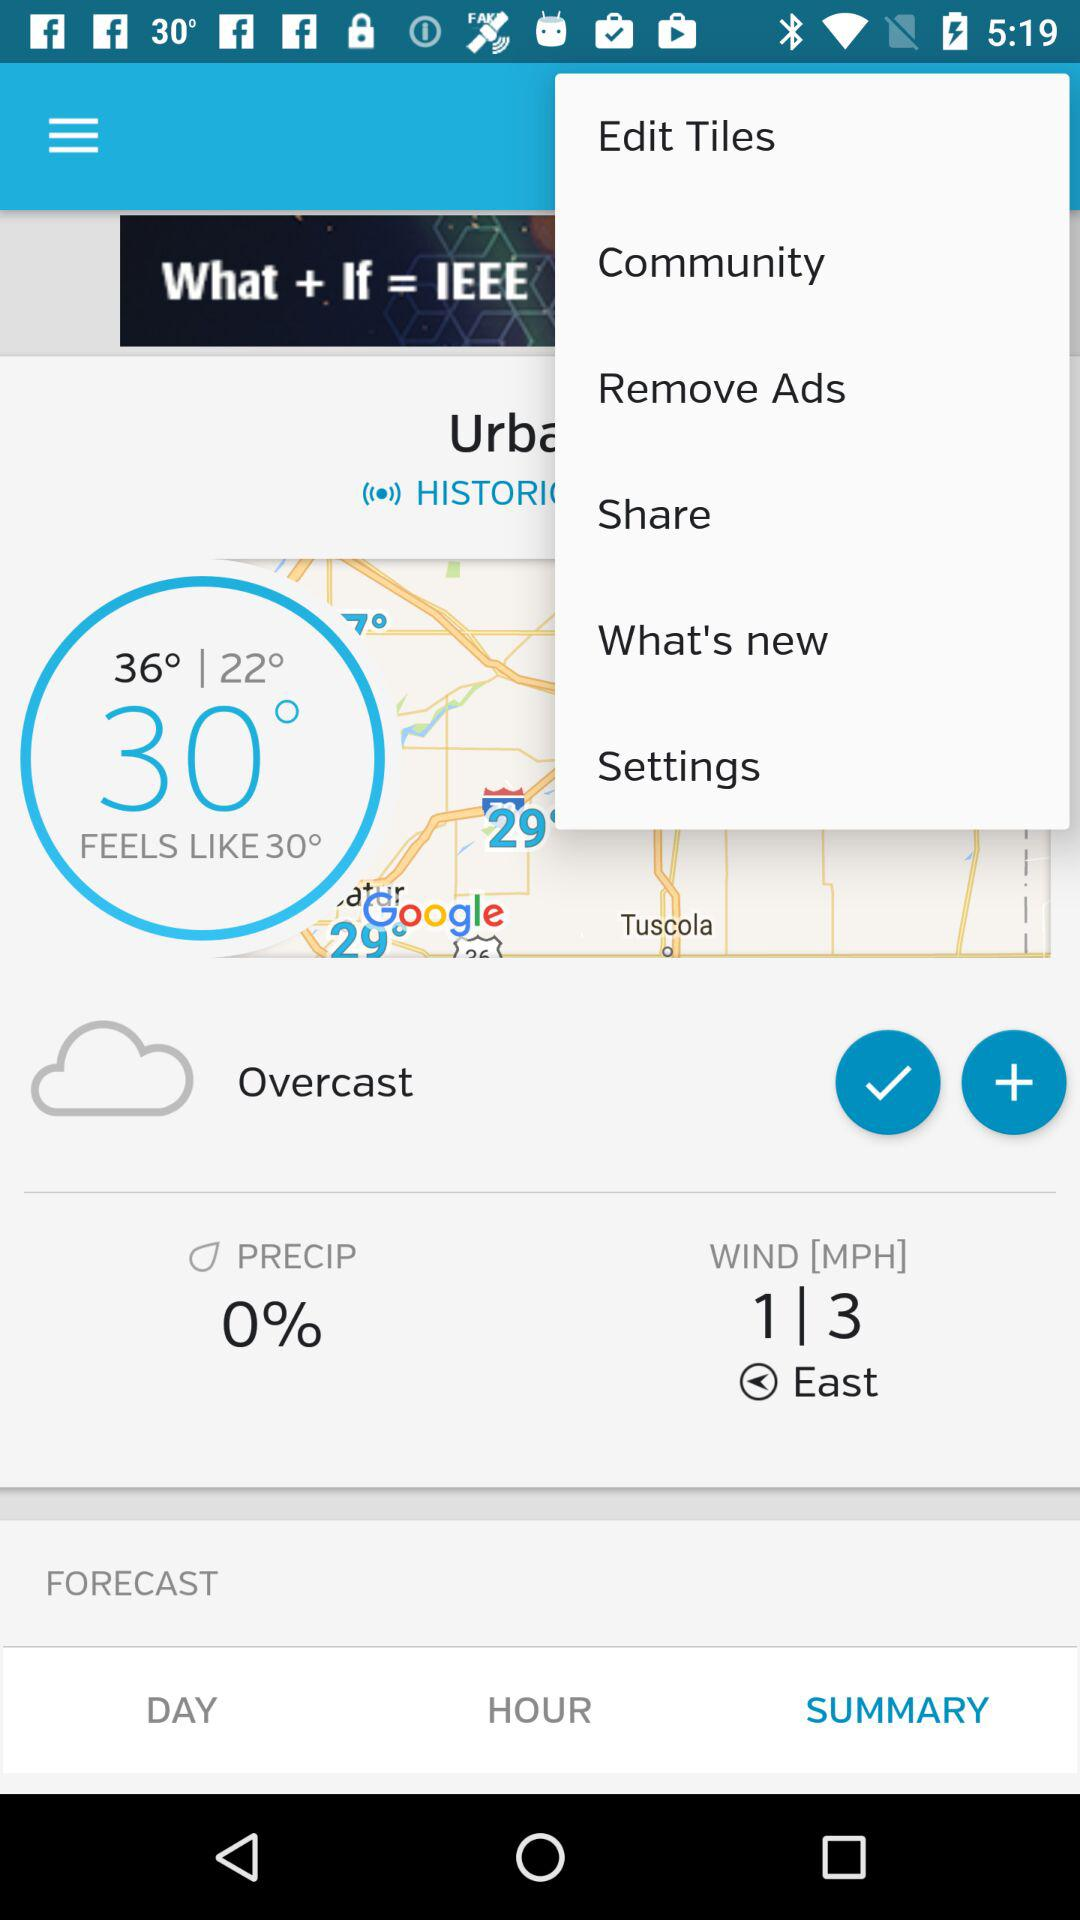How can the content be shared?
When the provided information is insufficient, respond with <no answer>. <no answer> 